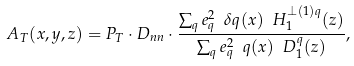<formula> <loc_0><loc_0><loc_500><loc_500>A _ { T } ( x , y , z ) = P _ { T } \cdot D _ { n n } \cdot \frac { \sum _ { q } e ^ { 2 } _ { q } \ \delta q ( x ) \ H _ { 1 } ^ { \perp ( 1 ) q } ( z ) } { \sum _ { q } e ^ { 2 } _ { q } \ q ( x ) \ D ^ { q } _ { 1 } ( z ) } ,</formula> 